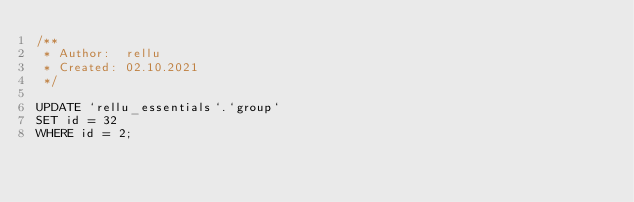Convert code to text. <code><loc_0><loc_0><loc_500><loc_500><_SQL_>/**
 * Author:  rellu
 * Created: 02.10.2021
 */

UPDATE `rellu_essentials`.`group` 
SET id = 32
WHERE id = 2;</code> 